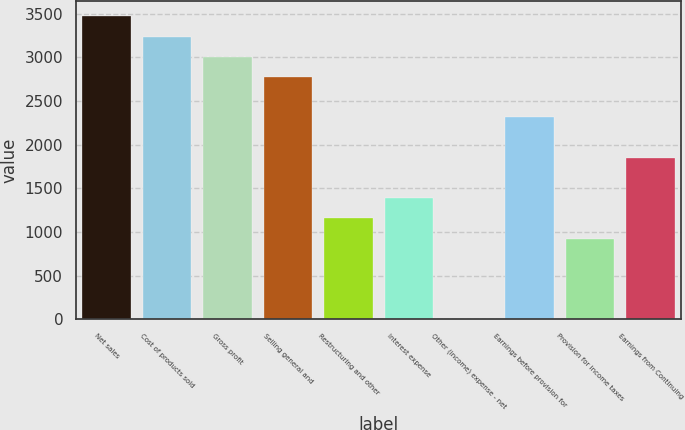Convert chart to OTSL. <chart><loc_0><loc_0><loc_500><loc_500><bar_chart><fcel>Net sales<fcel>Cost of products sold<fcel>Gross profit<fcel>Selling general and<fcel>Restructuring and other<fcel>Interest expense<fcel>Other (income) expense - net<fcel>Earnings before provision for<fcel>Provision for income taxes<fcel>Earnings from Continuing<nl><fcel>3467.7<fcel>3236.58<fcel>3005.46<fcel>2774.34<fcel>1156.5<fcel>1387.62<fcel>0.9<fcel>2312.1<fcel>925.38<fcel>1849.86<nl></chart> 